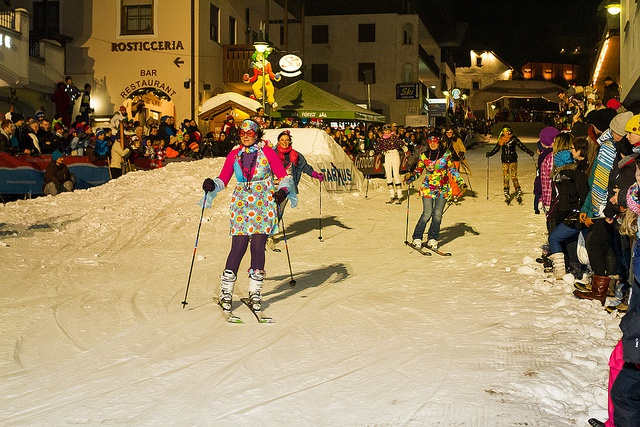Describe the objects in this image and their specific colors. I can see people in black, maroon, and olive tones, people in black, maroon, brown, and beige tones, people in black, olive, maroon, and gray tones, people in black, navy, tan, and olive tones, and people in black, olive, and maroon tones in this image. 